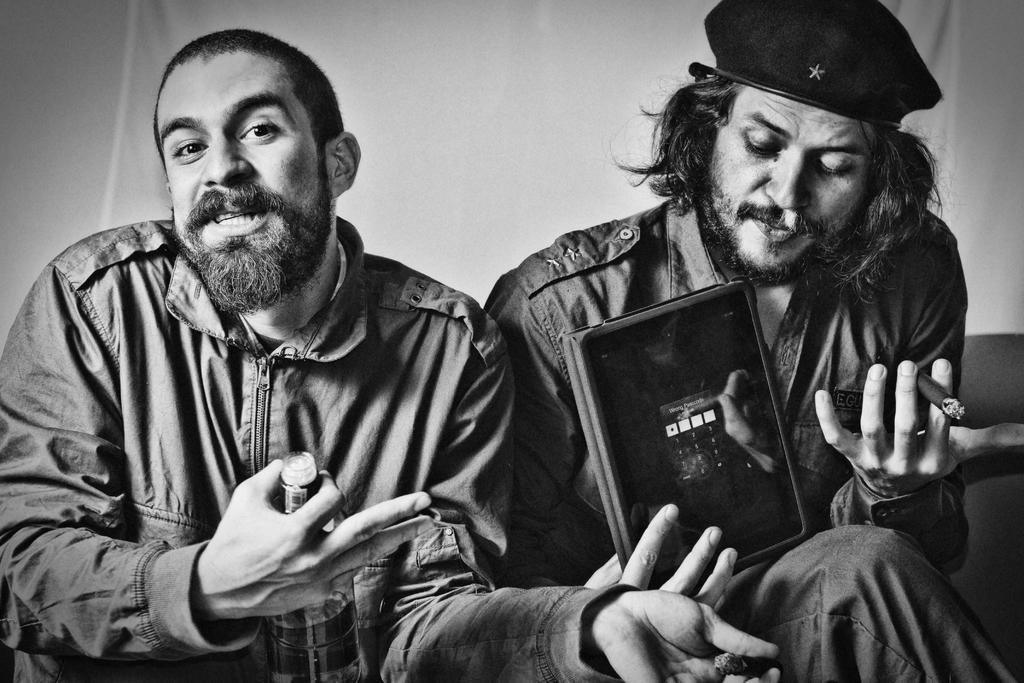Describe this image in one or two sentences. In the image two persons are sitting and holding a bottle and book and cigarette. Behind them there is a curtain. 